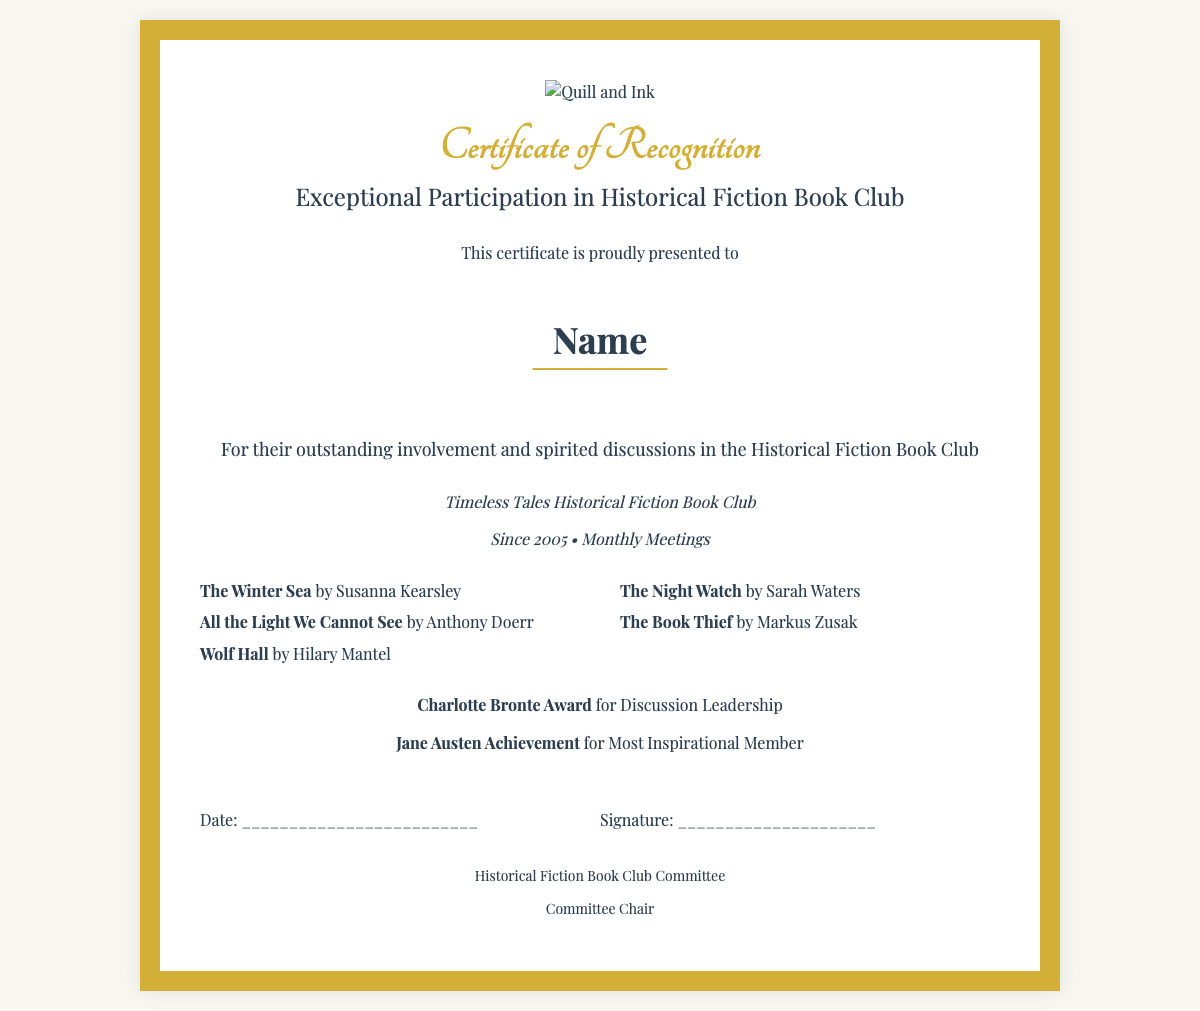What is the title of the certificate? The title on the certificate is prominently displayed as "Certificate of Recognition".
Answer: Certificate of Recognition Who is the certificate awarded to? The recipient's name is specified in the section dedicated to them, which states "This certificate is proudly presented to".
Answer: Name What club is this certificate associated with? The club mentioned in the document is "Timeless Tales Historical Fiction Book Club".
Answer: Timeless Tales Historical Fiction Book Club When did the club start? The document indicates the club has been active since the year mentioned: "Since 2005".
Answer: 2005 Which book is authored by Susanna Kearsley listed on the certificate? One of the listed books is specifically noted under "The books" section as written by Susanna Kearsley.
Answer: The Winter Sea What award is given for Discussion Leadership? The document specifies an award under "special mentions" for this achievement.
Answer: Charlotte Bronte Award What does the issuer of the certificate represent? The issuer is identified in the section dedicated to the committee at the end of the certificate.
Answer: Historical Fiction Book Club Committee How many books are listed on the certificate? The count of books provided in the "books" section contributes to the total number.
Answer: Five 